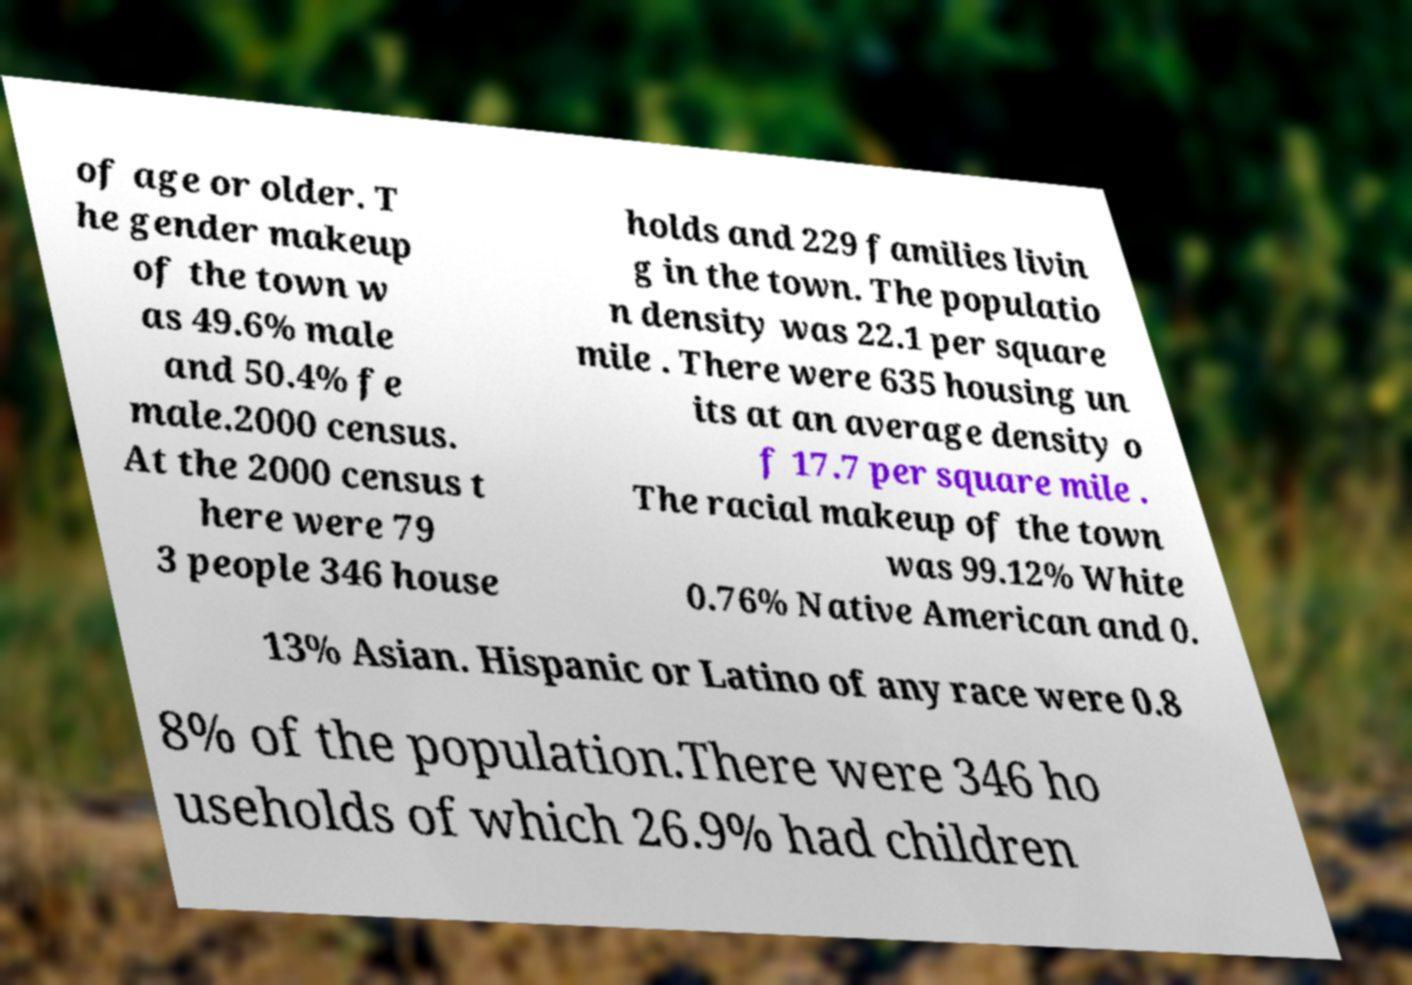There's text embedded in this image that I need extracted. Can you transcribe it verbatim? of age or older. T he gender makeup of the town w as 49.6% male and 50.4% fe male.2000 census. At the 2000 census t here were 79 3 people 346 house holds and 229 families livin g in the town. The populatio n density was 22.1 per square mile . There were 635 housing un its at an average density o f 17.7 per square mile . The racial makeup of the town was 99.12% White 0.76% Native American and 0. 13% Asian. Hispanic or Latino of any race were 0.8 8% of the population.There were 346 ho useholds of which 26.9% had children 